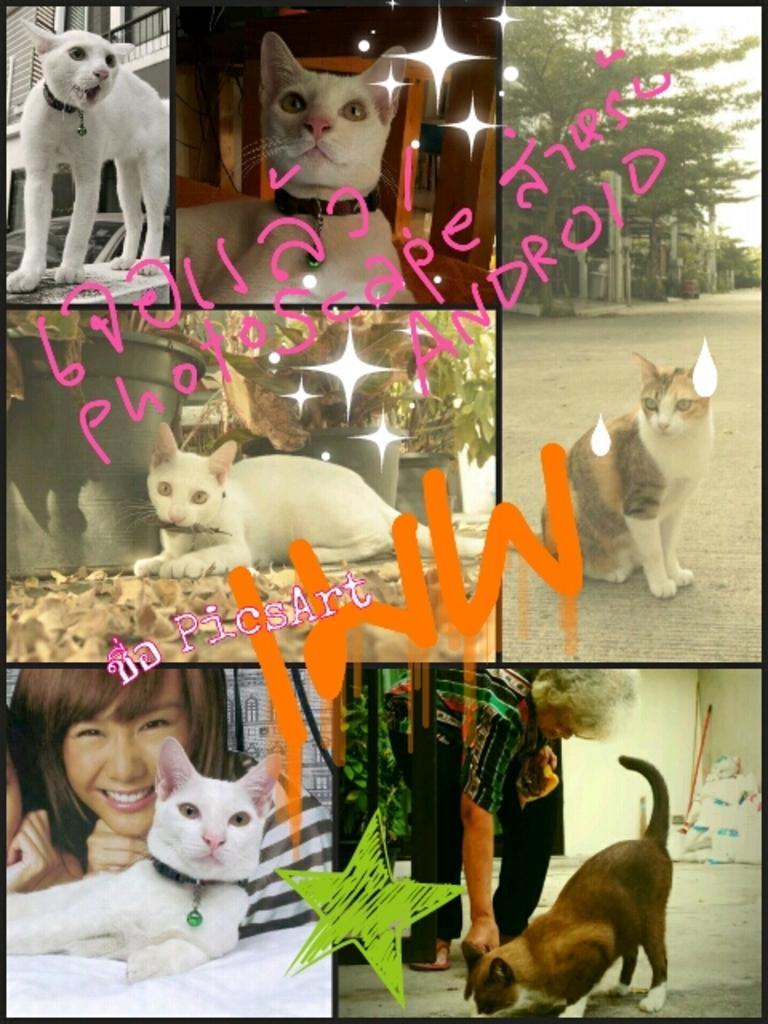Could you give a brief overview of what you see in this image? This picture is the collage of 6 images in which there are animals. On the right side there is a cat sitting on the road and in the background there are trees and at the bottom there are two images in which there are persons with animals. At the top left there is a cat which is white in colour standing on the floor and in the background there is a building and the image which is in the center there is a cat sitting on the ground and in the background there are plants in the pots. 